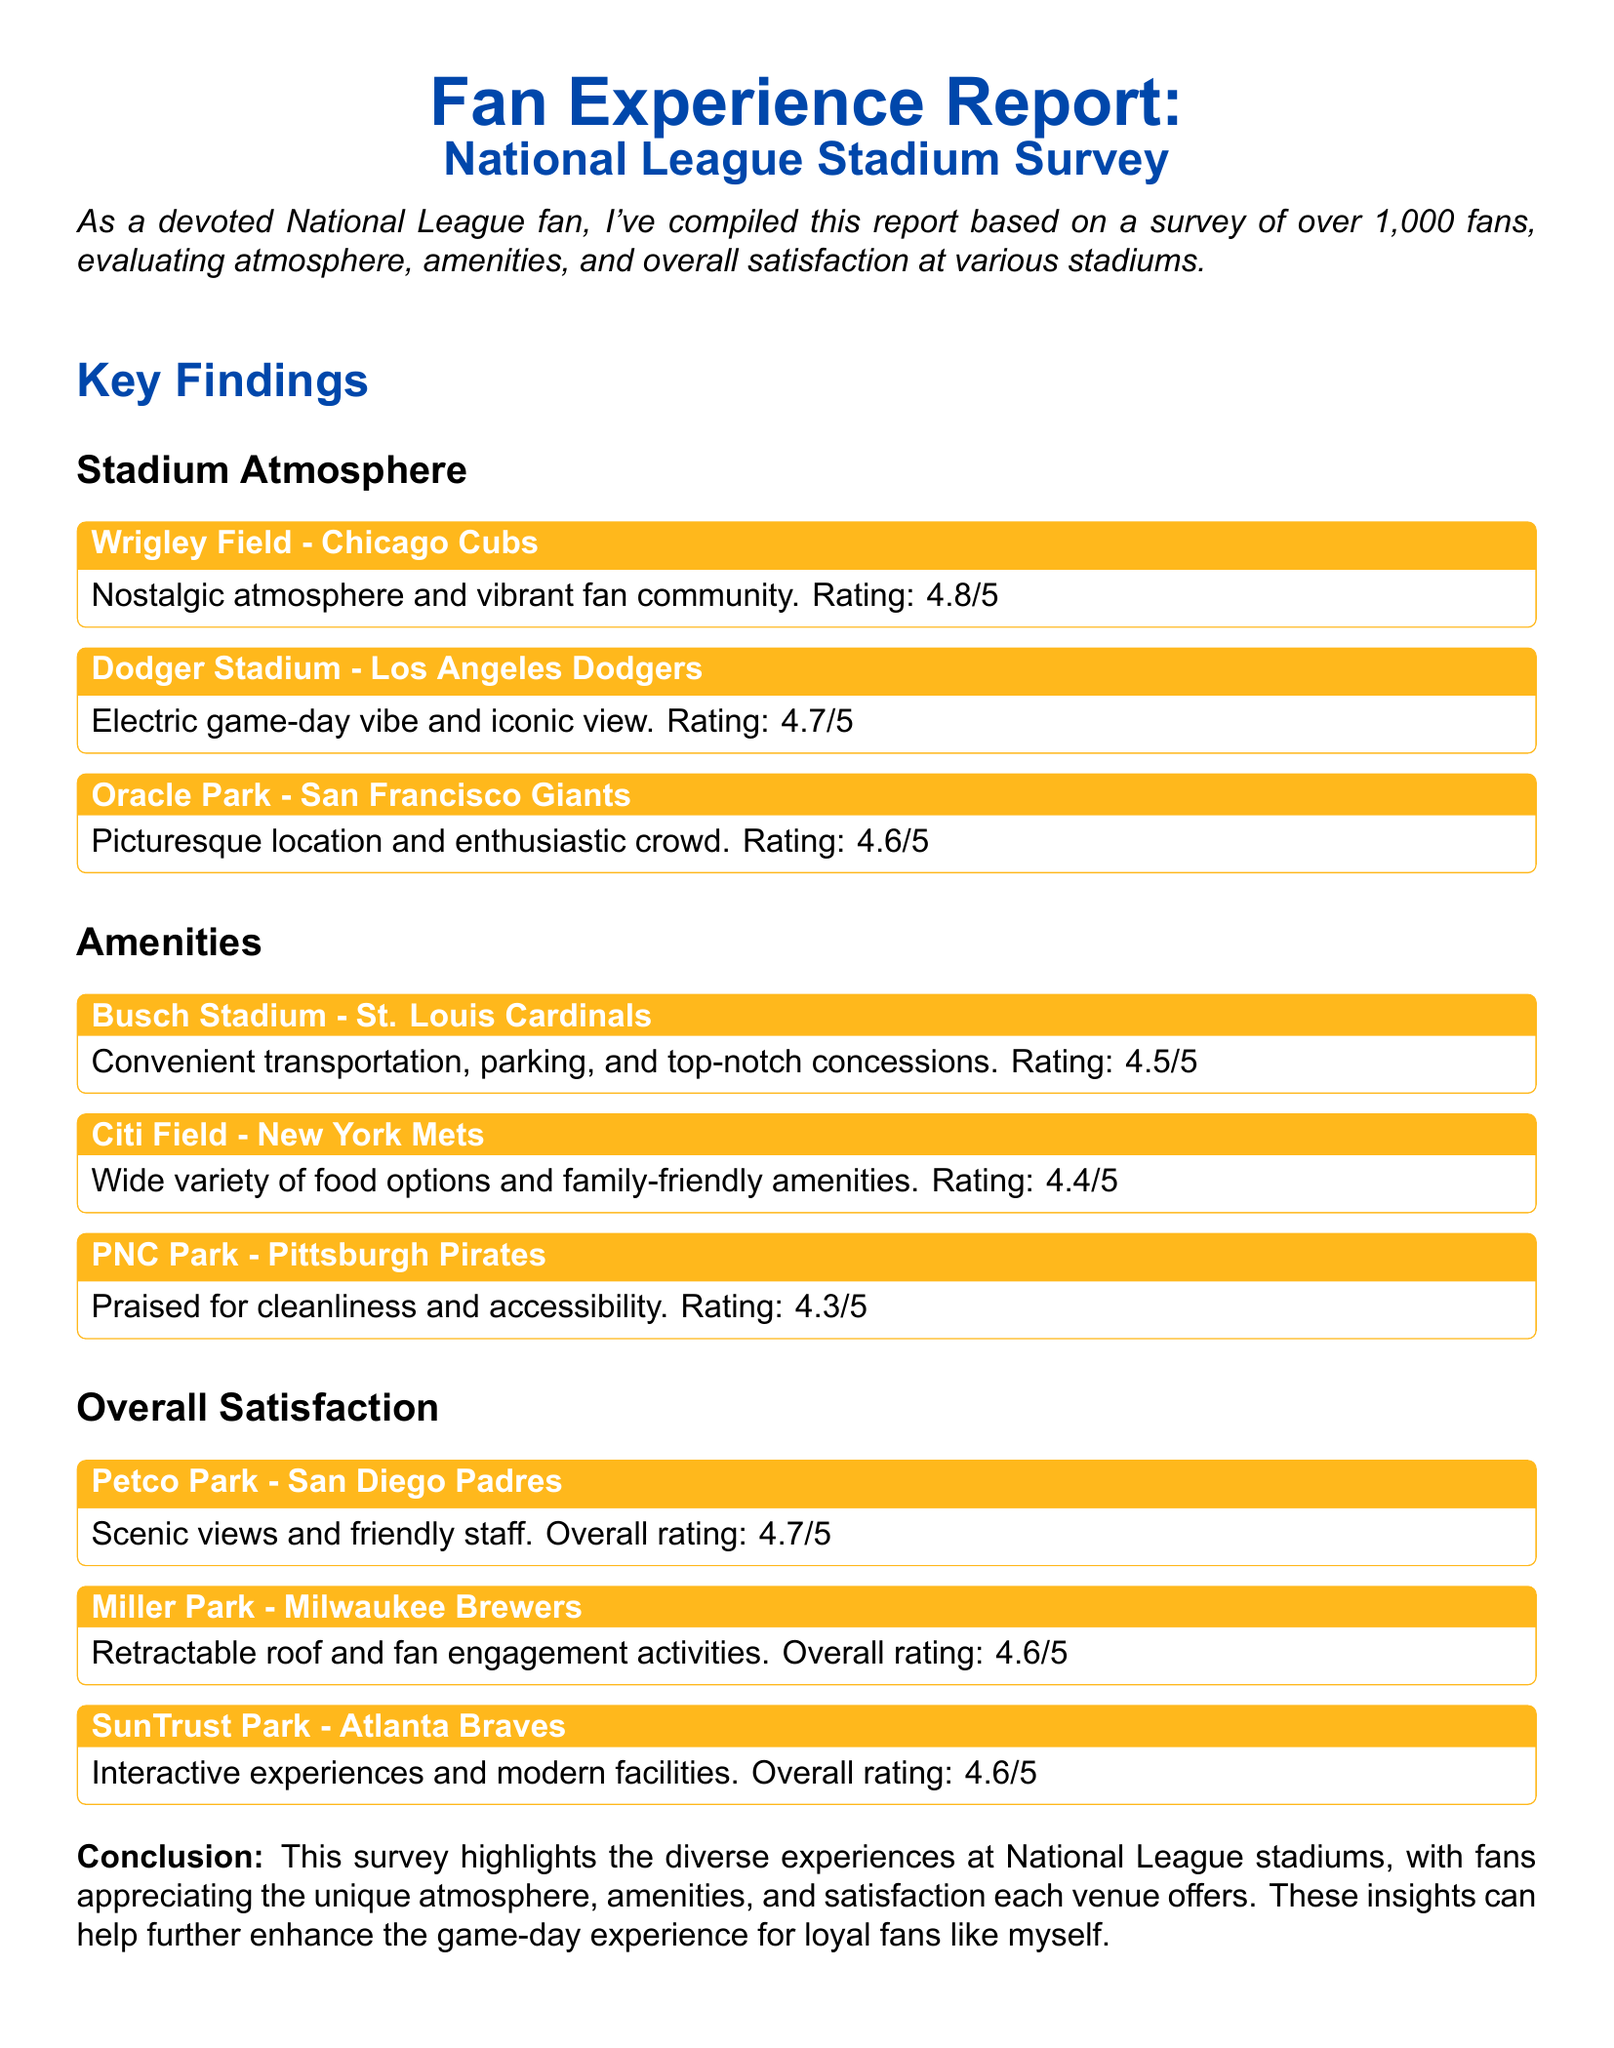What is the atmosphere rating for Wrigley Field? The atmosphere rating for Wrigley Field is mentioned in the findings section of the document as 4.8 out of 5.
Answer: 4.8/5 Which stadium is noted for its electric game-day vibe? The document highlights Dodger Stadium for its electric game-day vibe in the atmosphere section.
Answer: Dodger Stadium What amenities rating does Citi Field receive? The amenities rating for Citi Field is provided as 4.4/5 in the amenities section of the document.
Answer: 4.4/5 How many fans were surveyed for this report? The total number of fans surveyed is mentioned in the introduction as over 1,000.
Answer: over 1,000 What overall satisfaction rating does Miller Park have? The overall satisfaction rating for Miller Park is listed in the findings as 4.6/5.
Answer: 4.6/5 Which stadium is praised for its cleanliness and accessibility? The document specifies that PNC Park receives praise for its cleanliness and accessibility in the amenities section.
Answer: PNC Park Which aspect do fans appreciate according to the conclusion? The conclusion states that fans appreciate the unique atmosphere, amenities, and satisfaction each venue offers.
Answer: unique atmosphere What is the title of the document? The title of the document is clearly given at the beginning as "Fan Experience Report: National League Stadium Survey."
Answer: Fan Experience Report: National League Stadium Survey Which stadium is noted for modern facilities? The document highlights SunTrust Park for its modern facilities in the overall satisfaction section.
Answer: SunTrust Park 